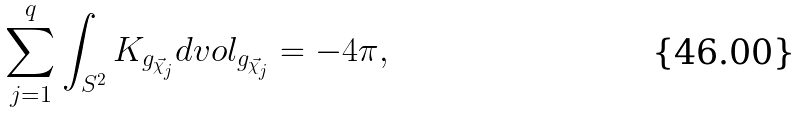Convert formula to latex. <formula><loc_0><loc_0><loc_500><loc_500>\sum _ { j = 1 } ^ { q } \int _ { S ^ { 2 } } K _ { g _ { \vec { \chi } _ { j } } } d v o l _ { g _ { \vec { \chi } _ { j } } } = - 4 \pi ,</formula> 